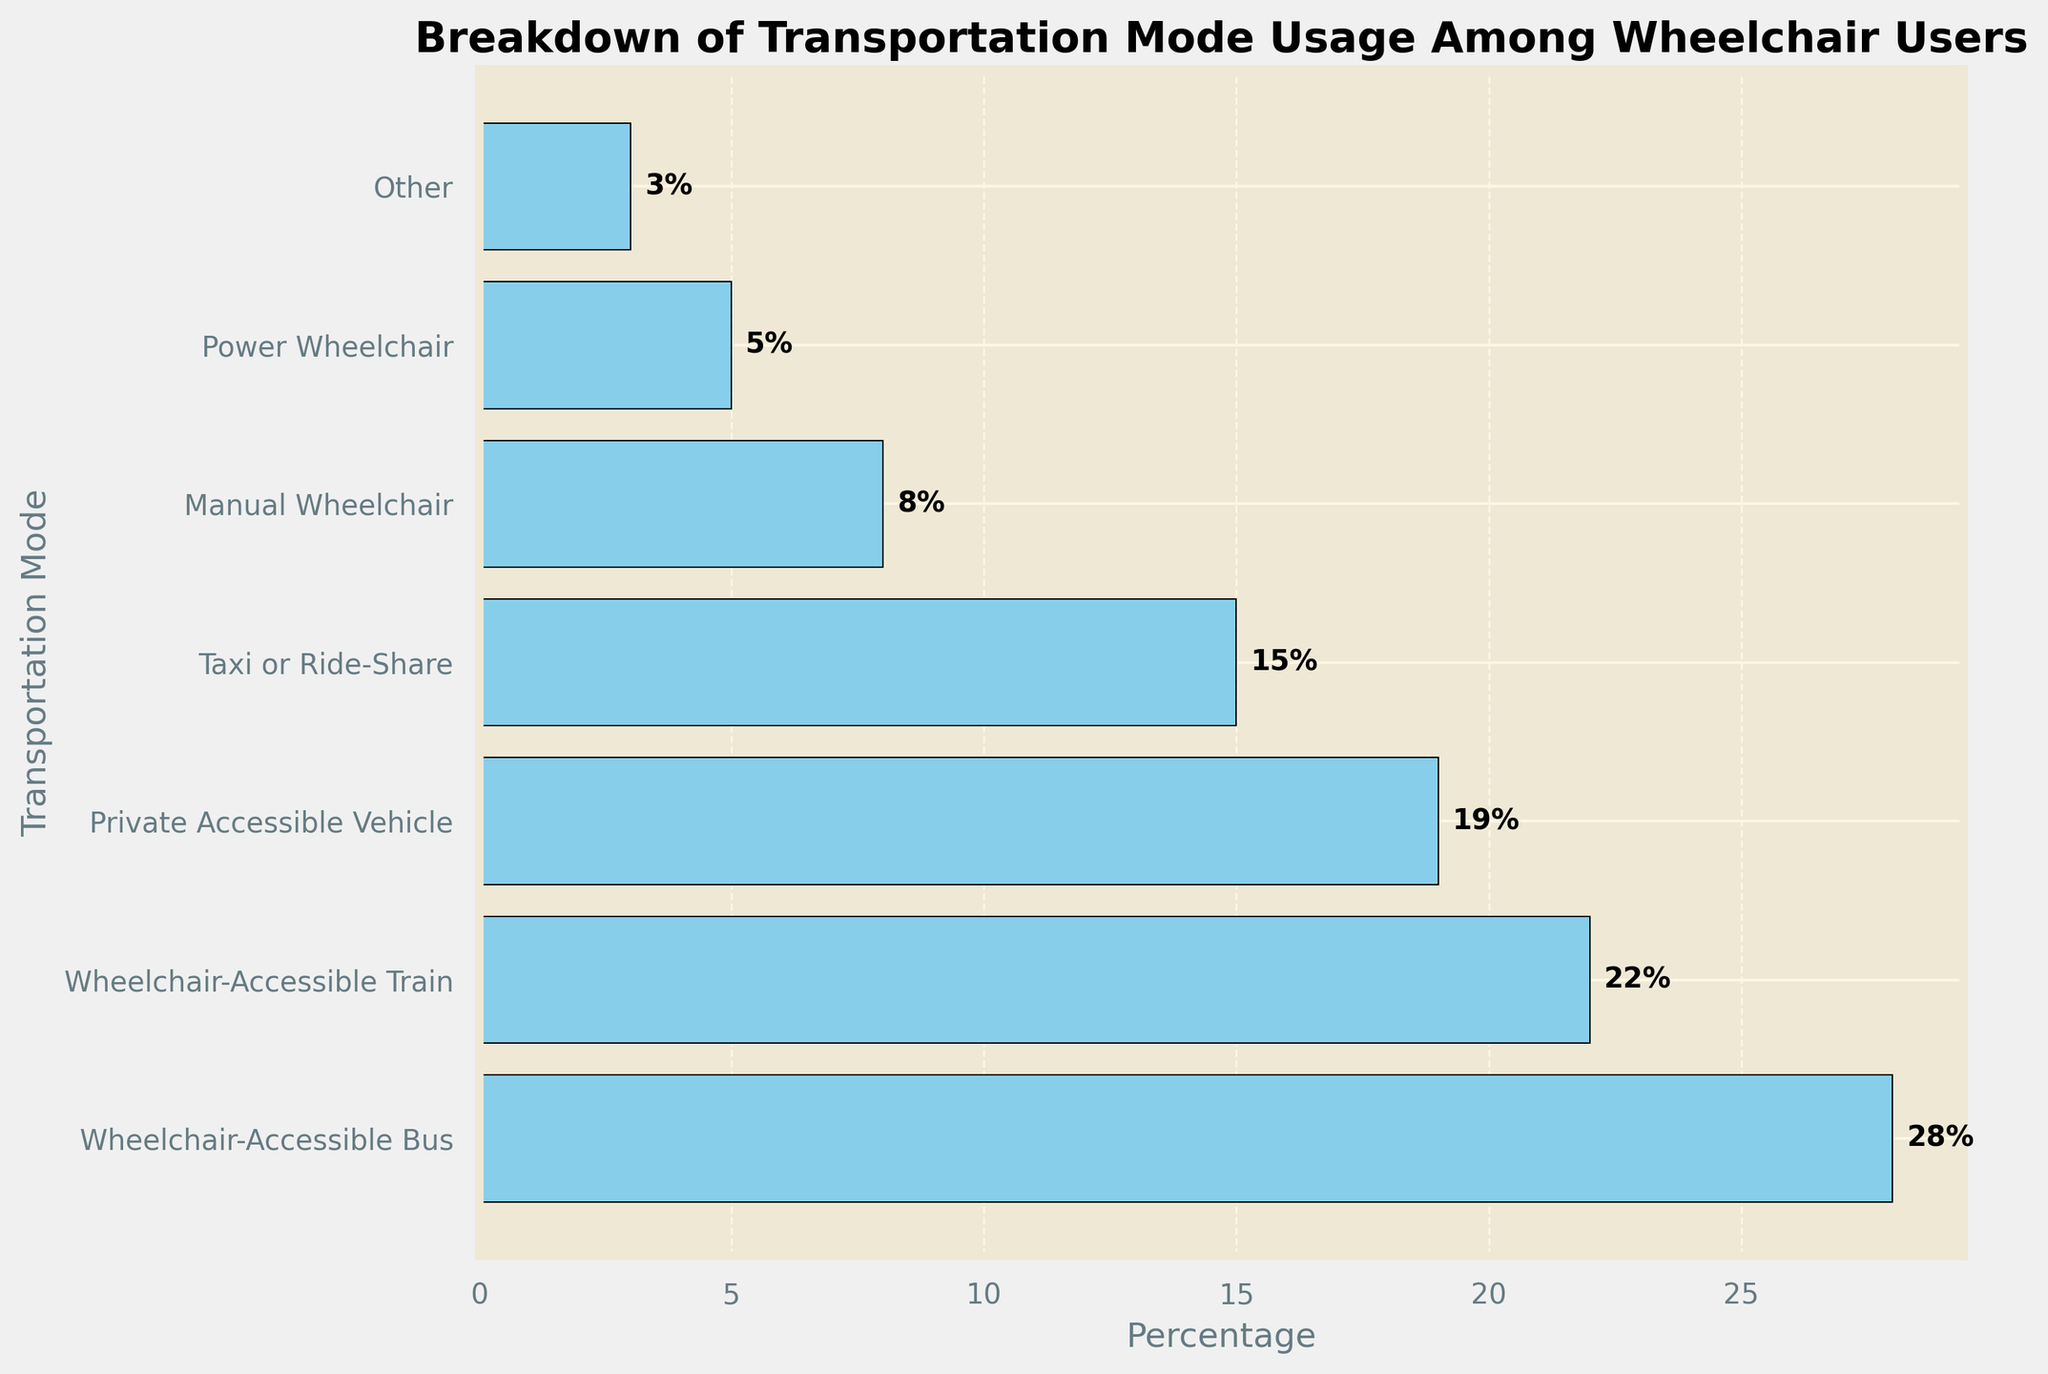How many modes of transportation have a percentage greater than or equal to 15? First, identify the modes of transportation and their respective percentages. The modes are Wheelchair-Accessible Bus (28%), Wheelchair-Accessible Train (22%), Private Accessible Vehicle (19%), and Taxi or Ride-Share (15%). Since all these percentages are greater than or equal to 15%, that's 4 modes.
Answer: 4 What is the combined percentage of users who prefer either Private Accessible Vehicles or Taxis/Ride-Share services? Look at the percentages for Private Accessible Vehicles (19%) and Taxis/Ride-Share (15%). Sum these percentages: 19% + 15% = 34%.
Answer: 34% Which mode of transportation is used the least by wheelchair users? Identify the mode with the smallest percentage. The "Other" category has the smallest percentage at 3%.
Answer: Other What is the percentage difference between usage of Wheelchair-Accessible Buses and Manual Wheelchairs? Subtract the percentage of Manual Wheelchairs (8%) from the percentage of Wheelchair-Accessible Buses (28%): 28% - 8% = 20%.
Answer: 20% Which two modes of transportation have the closest usage percentages? Compare the percentages of all modes, noting the differences. Wheelchair-Accessible Train is 22% and Private Accessible Vehicle is 19%, with a difference of 3%, the smallest difference among the modes.
Answer: Wheelchair-Accessible Train and Private Accessible Vehicle Is the usage percentage of Power Wheelchairs greater than Manual Wheelchairs? Compare the two percentages. Power Wheelchair usage is 5% and Manual Wheelchair usage is 8%. Since 5% is less than 8%, the usage of Power Wheelchairs is not greater.
Answer: No What is the average percentage of the three most popular transportation modes? The three most popular modes are Wheelchair-Accessible Bus (28%), Wheelchair-Accessible Train (22%), and Private Accessible Vehicle (19%). Calculate the average: (28% + 22% + 19%) / 3 = 23%.
Answer: 23% By how much does the preference for Wheelchair-Accessible Trains exceed the combined percentage for Power Wheelchairs and "Other"? First, find the combined percentage of Power Wheelchairs (5%) and "Other" (3%): 5% + 3% = 8%. Then, subtract this combined percentage from the percentage for Wheelchair-Accessible Trains (22%): 22% - 8% = 14%.
Answer: 14% 